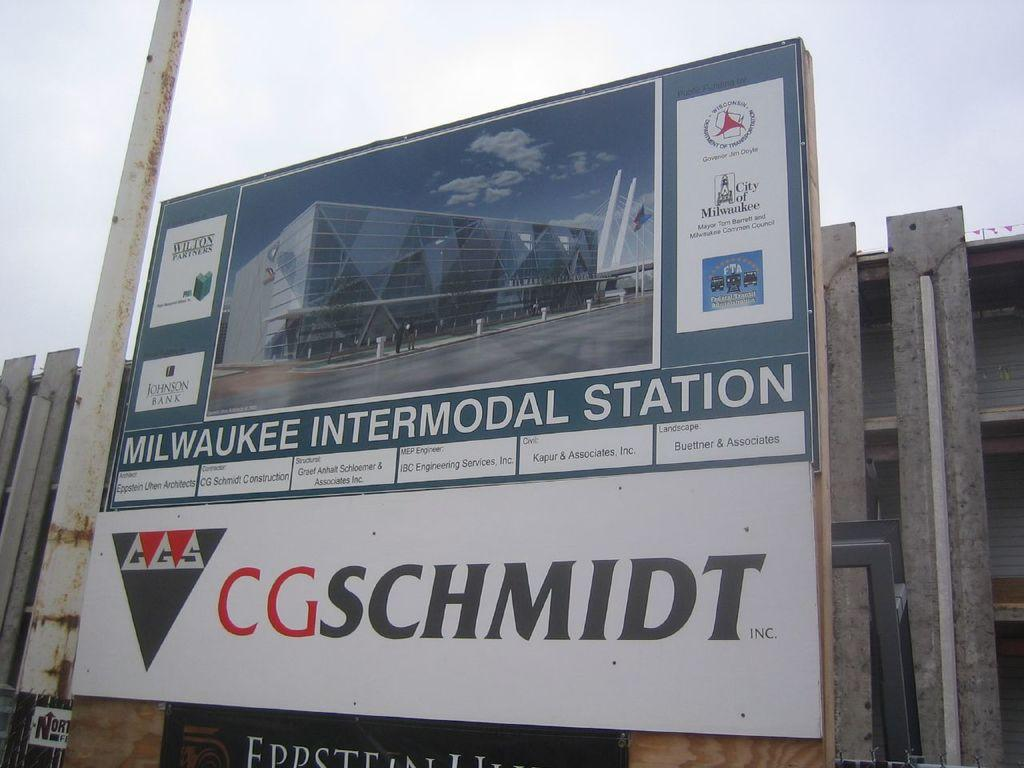<image>
Present a compact description of the photo's key features. A sign for the Milwaukee Intermodal Station by CGSchmidt. 